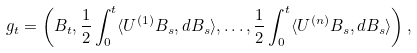<formula> <loc_0><loc_0><loc_500><loc_500>g _ { t } = \left ( B _ { t } , \frac { 1 } { 2 } \int _ { 0 } ^ { t } \langle U ^ { ( 1 ) } B _ { s } , d B _ { s } \rangle , \dots , \frac { 1 } { 2 } \int _ { 0 } ^ { t } \langle U ^ { ( n ) } B _ { s } , d B _ { s } \rangle \right ) ,</formula> 